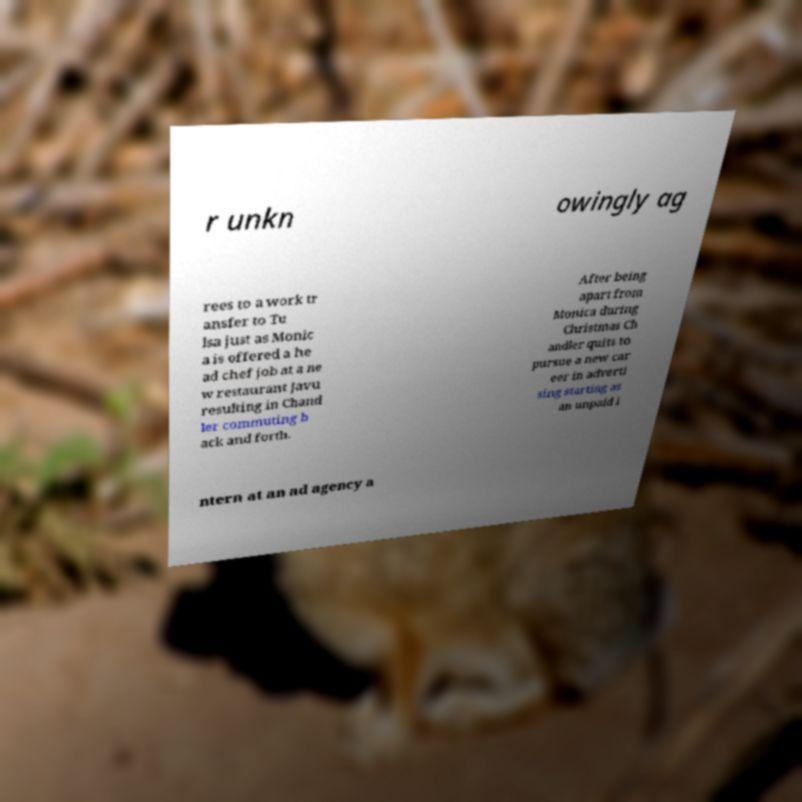Could you assist in decoding the text presented in this image and type it out clearly? r unkn owingly ag rees to a work tr ansfer to Tu lsa just as Monic a is offered a he ad chef job at a ne w restaurant Javu resulting in Chand ler commuting b ack and forth. After being apart from Monica during Christmas Ch andler quits to pursue a new car eer in adverti sing starting as an unpaid i ntern at an ad agency a 